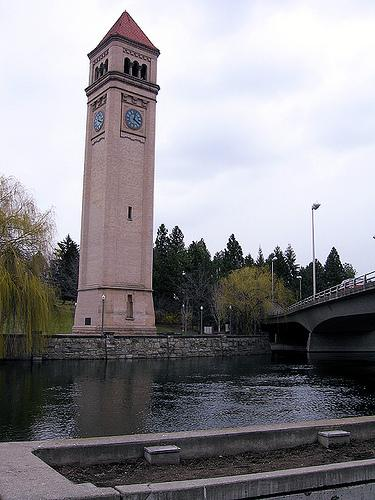What is the clock attached to? tower 